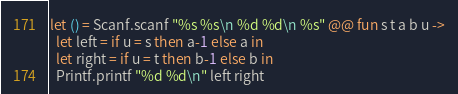<code> <loc_0><loc_0><loc_500><loc_500><_OCaml_>let () = Scanf.scanf "%s %s\n %d %d\n %s" @@ fun s t a b u ->
  let left = if u = s then a-1 else a in
  let right = if u = t then b-1 else b in
  Printf.printf "%d %d\n" left right</code> 